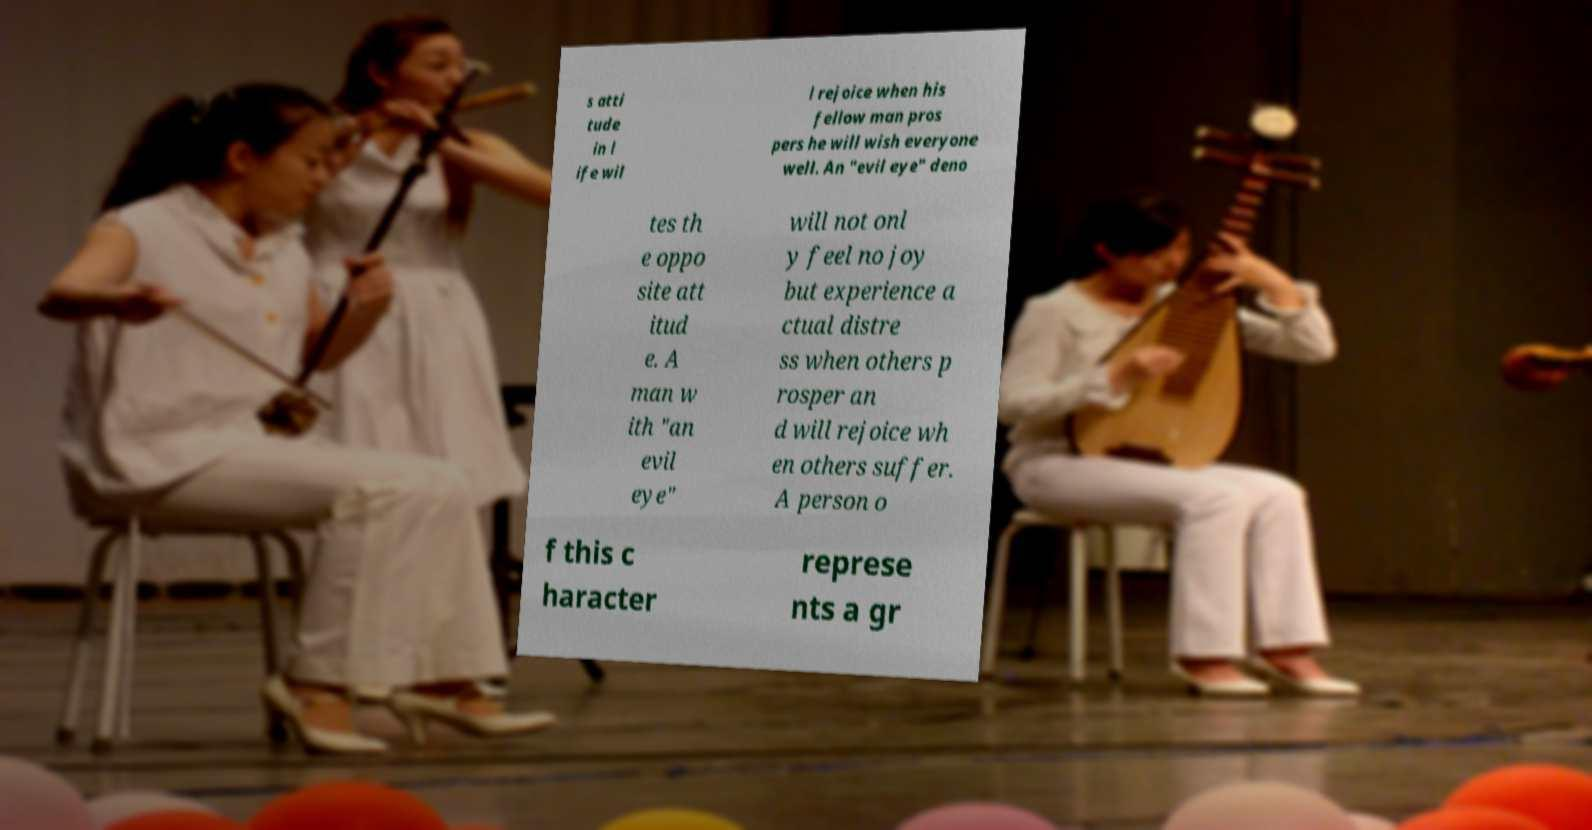What messages or text are displayed in this image? I need them in a readable, typed format. s atti tude in l ife wil l rejoice when his fellow man pros pers he will wish everyone well. An "evil eye" deno tes th e oppo site att itud e. A man w ith "an evil eye" will not onl y feel no joy but experience a ctual distre ss when others p rosper an d will rejoice wh en others suffer. A person o f this c haracter represe nts a gr 